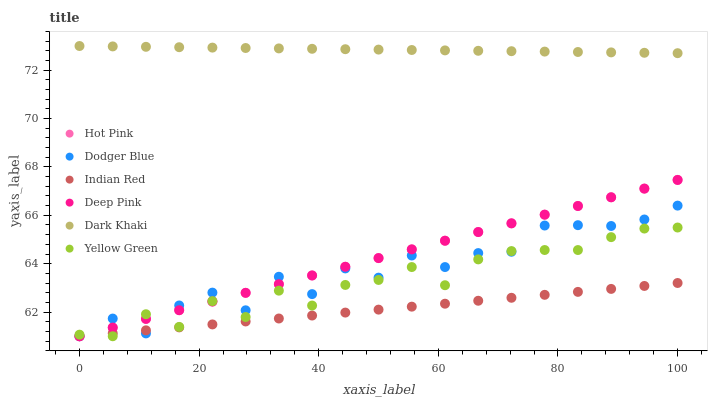Does Indian Red have the minimum area under the curve?
Answer yes or no. Yes. Does Dark Khaki have the maximum area under the curve?
Answer yes or no. Yes. Does Yellow Green have the minimum area under the curve?
Answer yes or no. No. Does Yellow Green have the maximum area under the curve?
Answer yes or no. No. Is Indian Red the smoothest?
Answer yes or no. Yes. Is Dodger Blue the roughest?
Answer yes or no. Yes. Is Yellow Green the smoothest?
Answer yes or no. No. Is Yellow Green the roughest?
Answer yes or no. No. Does Deep Pink have the lowest value?
Answer yes or no. Yes. Does Dark Khaki have the lowest value?
Answer yes or no. No. Does Dark Khaki have the highest value?
Answer yes or no. Yes. Does Yellow Green have the highest value?
Answer yes or no. No. Is Yellow Green less than Dark Khaki?
Answer yes or no. Yes. Is Dark Khaki greater than Indian Red?
Answer yes or no. Yes. Does Yellow Green intersect Deep Pink?
Answer yes or no. Yes. Is Yellow Green less than Deep Pink?
Answer yes or no. No. Is Yellow Green greater than Deep Pink?
Answer yes or no. No. Does Yellow Green intersect Dark Khaki?
Answer yes or no. No. 